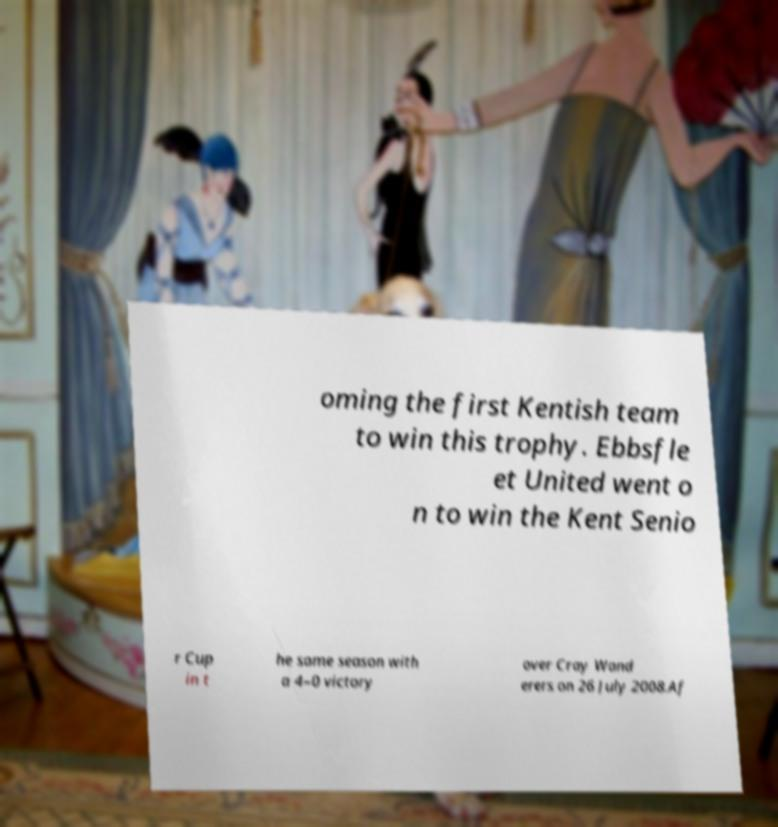Can you accurately transcribe the text from the provided image for me? oming the first Kentish team to win this trophy. Ebbsfle et United went o n to win the Kent Senio r Cup in t he same season with a 4–0 victory over Cray Wand erers on 26 July 2008.Af 